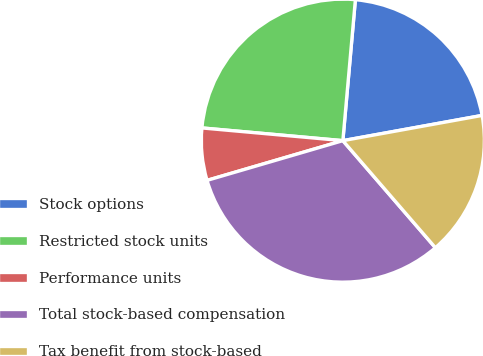Convert chart. <chart><loc_0><loc_0><loc_500><loc_500><pie_chart><fcel>Stock options<fcel>Restricted stock units<fcel>Performance units<fcel>Total stock-based compensation<fcel>Tax benefit from stock-based<nl><fcel>20.74%<fcel>24.98%<fcel>5.96%<fcel>31.82%<fcel>16.51%<nl></chart> 